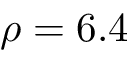<formula> <loc_0><loc_0><loc_500><loc_500>\rho = 6 . 4</formula> 